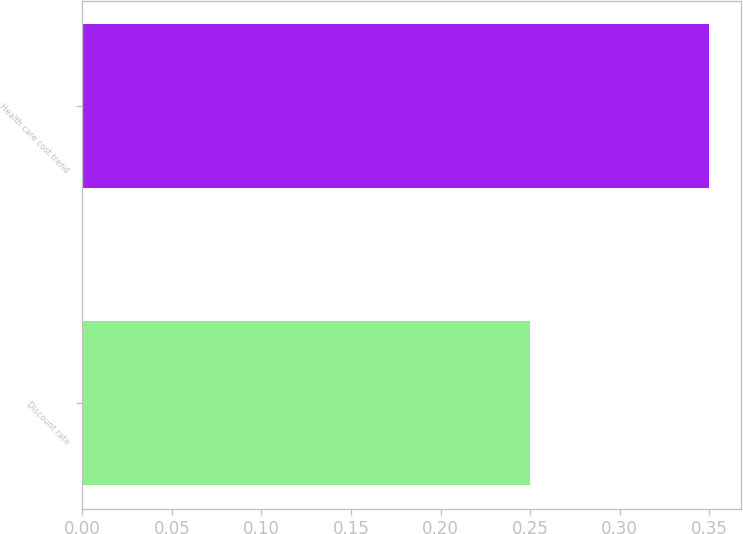Convert chart to OTSL. <chart><loc_0><loc_0><loc_500><loc_500><bar_chart><fcel>Discount rate<fcel>Health care cost trend<nl><fcel>0.25<fcel>0.35<nl></chart> 